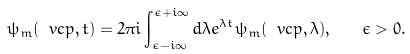<formula> <loc_0><loc_0><loc_500><loc_500>\psi _ { m } ( \ v c { p } , t ) = 2 \pi i \int _ { \epsilon - i \infty } ^ { \epsilon + i \infty } d \lambda e ^ { \lambda t } \psi _ { m } ( \ v c { p } , \lambda ) , \quad \epsilon > 0 .</formula> 